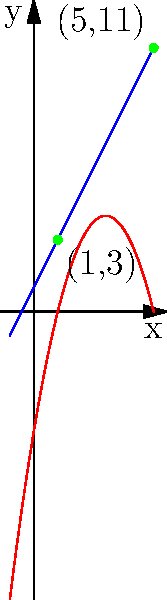As a patent attorney analyzing technological trends, you encounter two patent trend lines represented by the following equations:

Patent A: $y = 2x + 1$
Patent B: $y = -x^2 + 6x - 5$

Determine the x-coordinates of the intersection points of these two trend lines. Round your answer to two decimal places if necessary. To find the intersection points, we need to solve the system of equations:

$$2x + 1 = -x^2 + 6x - 5$$

Step 1: Rearrange the equation to standard form
$$x^2 + 2x - 6x + 5 - 1 = 0$$
$$x^2 - 4x + 4 = 0$$

Step 2: Recognize this as a quadratic equation in the form $ax^2 + bx + c = 0$
Where $a=1$, $b=-4$, and $c=4$

Step 3: Use the quadratic formula $x = \frac{-b \pm \sqrt{b^2 - 4ac}}{2a}$

$$x = \frac{4 \pm \sqrt{(-4)^2 - 4(1)(4)}}{2(1)}$$

$$x = \frac{4 \pm \sqrt{16 - 16}}{2}$$

$$x = \frac{4 \pm 0}{2}$$

$$x = 2$$

Step 4: Verify the solution
Both equations yield $y = 5$ when $x = 2$, confirming the intersection point (2, 5).

Step 5: Observe that there is only one solution, meaning the lines are tangent to each other at this point.
Answer: x = 2 